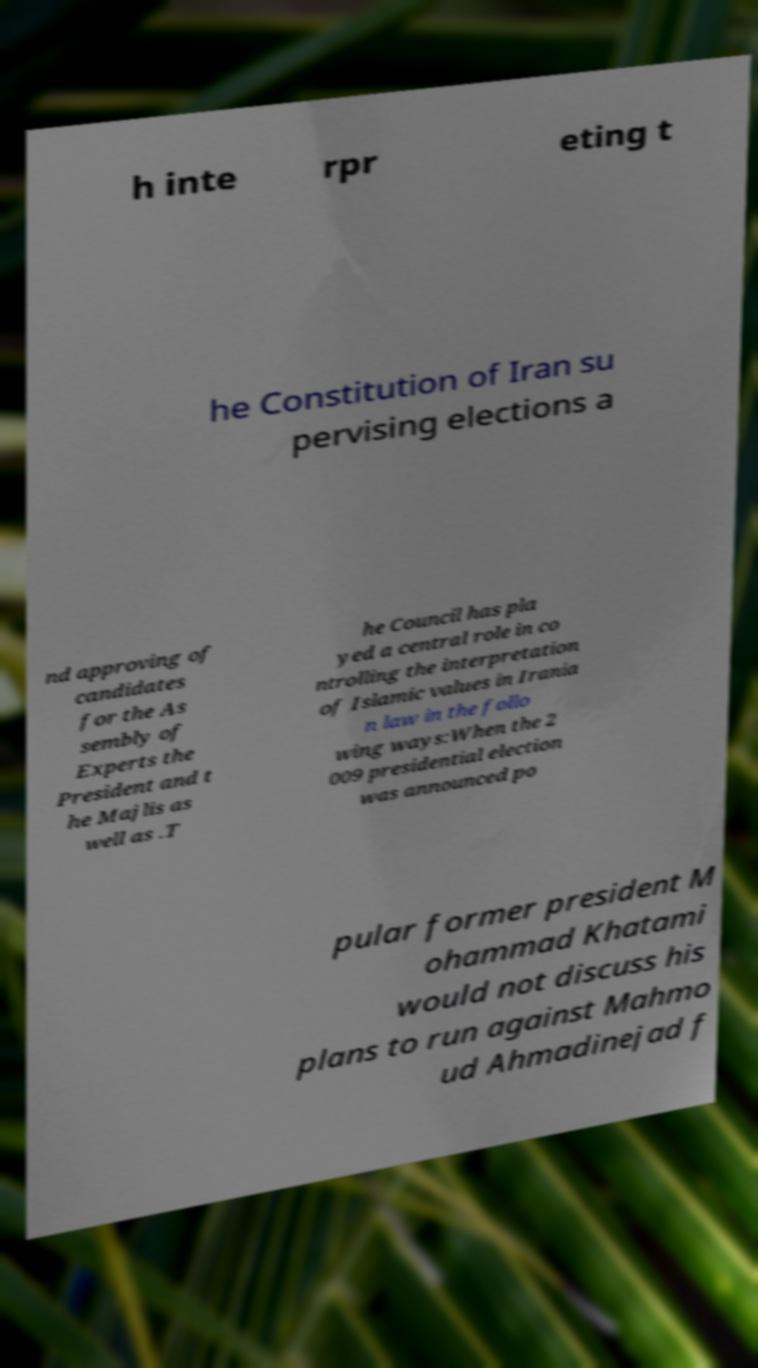Please identify and transcribe the text found in this image. h inte rpr eting t he Constitution of Iran su pervising elections a nd approving of candidates for the As sembly of Experts the President and t he Majlis as well as .T he Council has pla yed a central role in co ntrolling the interpretation of Islamic values in Irania n law in the follo wing ways:When the 2 009 presidential election was announced po pular former president M ohammad Khatami would not discuss his plans to run against Mahmo ud Ahmadinejad f 